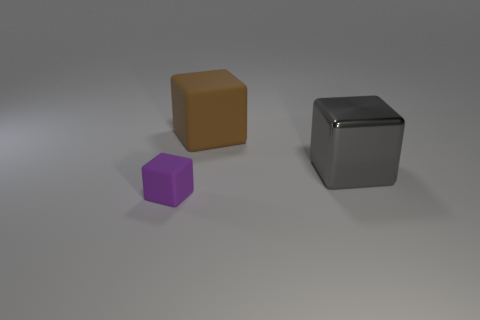There is a big object that is to the right of the brown object; what material is it?
Provide a short and direct response. Metal. How many objects are rubber blocks that are in front of the big gray metallic object or gray metal blocks?
Your response must be concise. 2. Are there an equal number of rubber blocks to the right of the tiny purple block and large rubber cubes?
Offer a terse response. Yes. Is the gray block the same size as the brown block?
Provide a short and direct response. Yes. There is a cube that is the same size as the metallic thing; what is its color?
Your answer should be very brief. Brown. Is the size of the brown object the same as the cube on the right side of the brown matte cube?
Keep it short and to the point. Yes. What number of things are small purple objects or objects that are behind the small block?
Offer a terse response. 3. Do the rubber thing behind the small purple rubber block and the rubber object in front of the gray metal block have the same size?
Keep it short and to the point. No. Are there any other blocks made of the same material as the tiny block?
Offer a terse response. Yes. There is a large gray object in front of the rubber block that is on the right side of the small purple cube; what shape is it?
Ensure brevity in your answer.  Cube. 